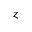<formula> <loc_0><loc_0><loc_500><loc_500>z</formula> 